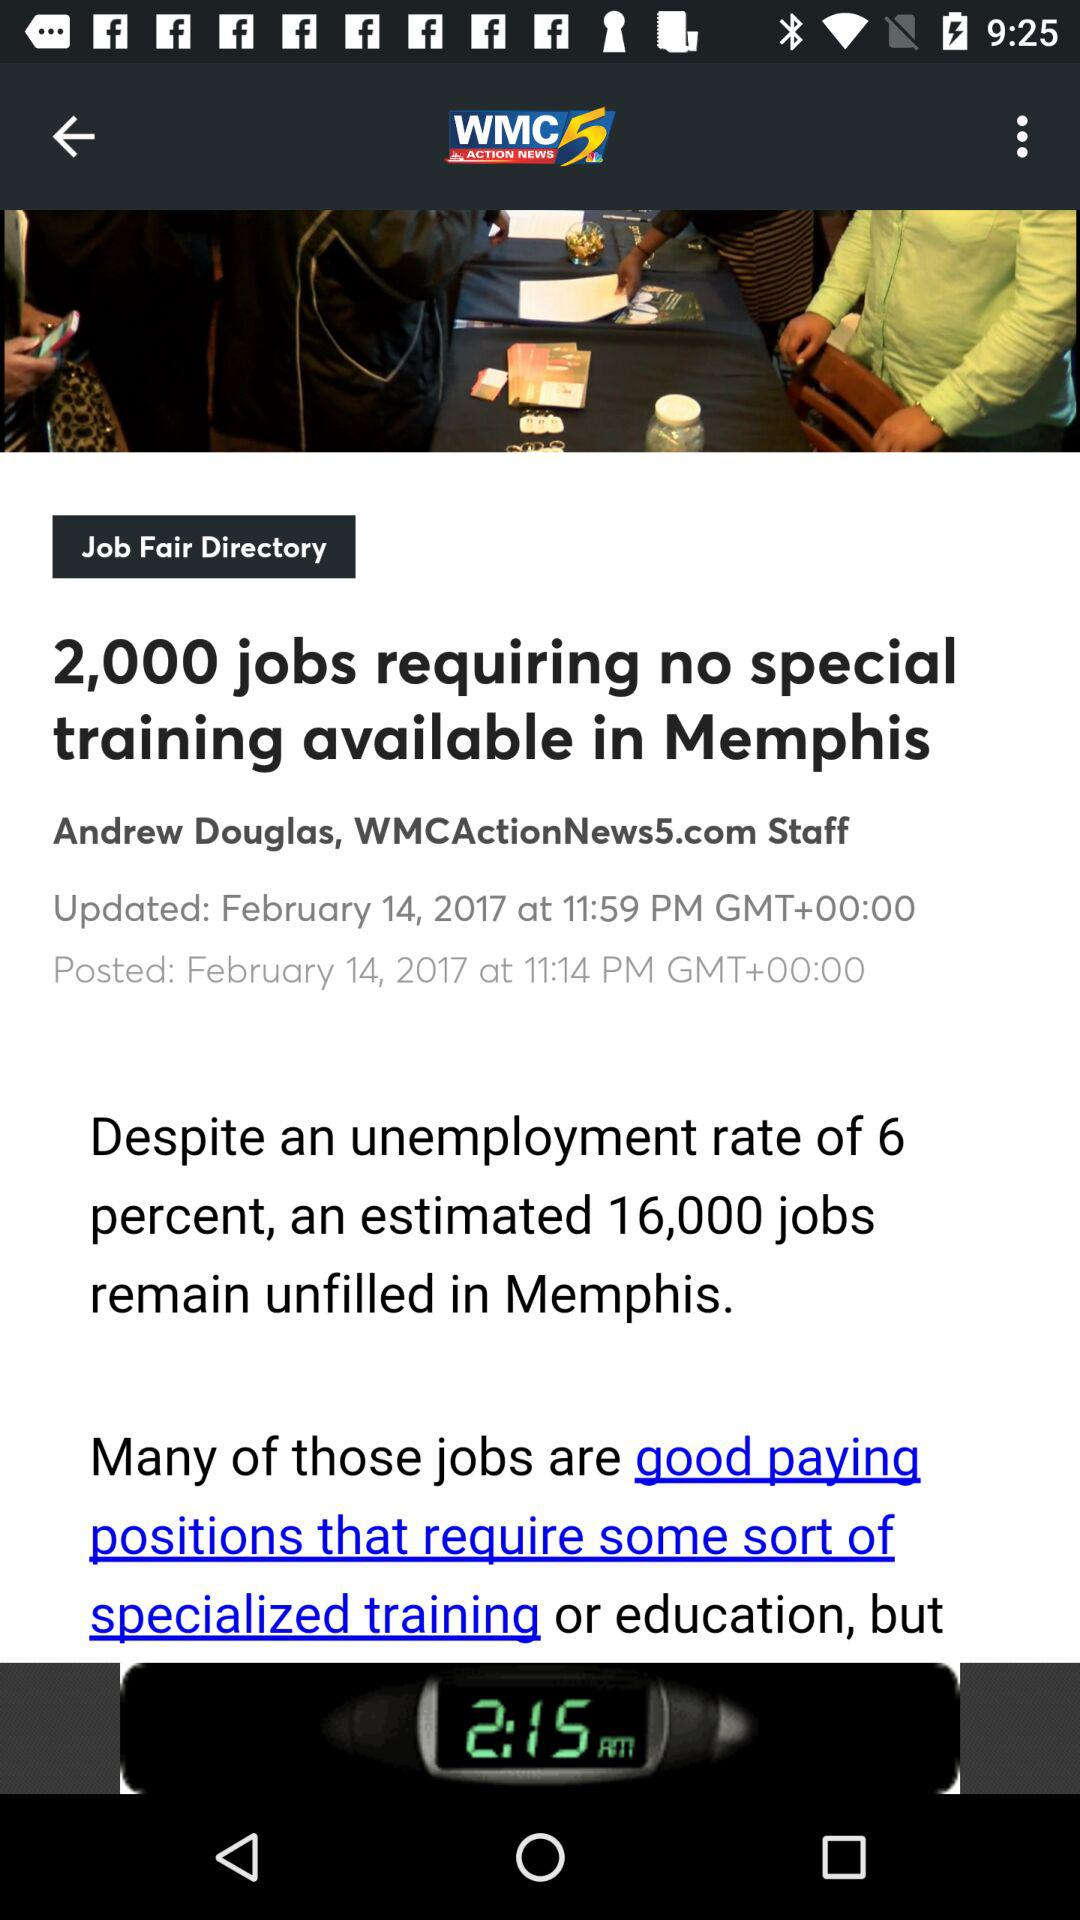How many more jobs are unfilled than require special training?
Answer the question using a single word or phrase. 14000 